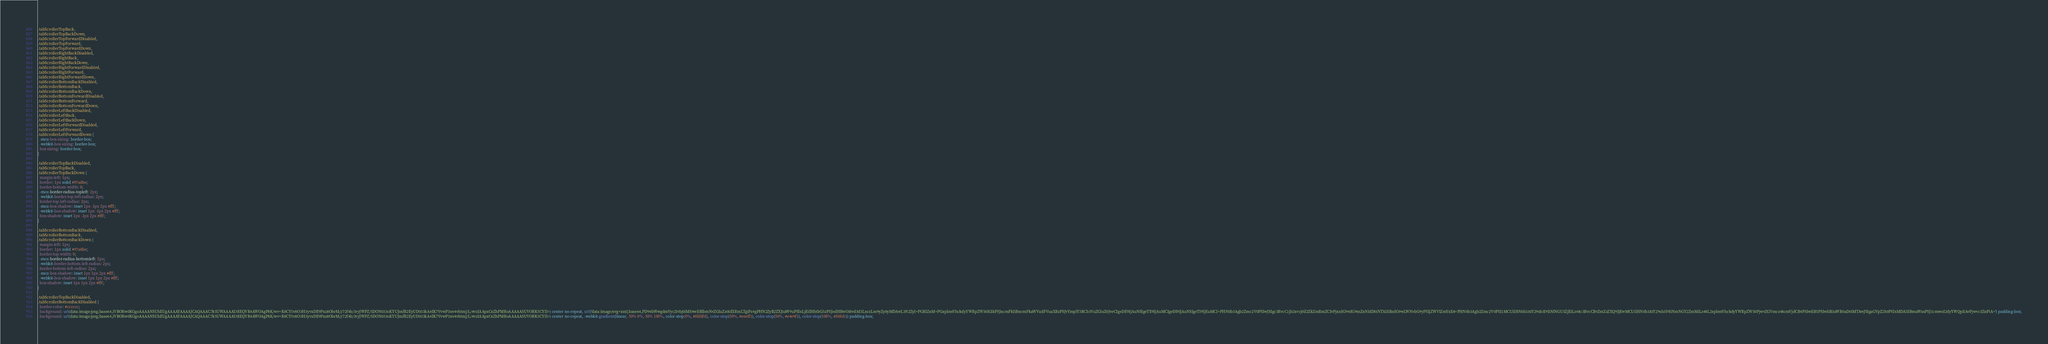Convert code to text. <code><loc_0><loc_0><loc_500><loc_500><_CSS_>.tabScrollerTopBack,
.tabScrollerTopBackDown,
.tabScrollerTopForwardDisabled,
.tabScrollerTopForward,
.tabScrollerTopForwardDown,
.tabScrollerRightBackDisabled,
.tabScrollerRightBack,
.tabScrollerRightBackDown,
.tabScrollerRightForwardDisabled,
.tabScrollerRightForward,
.tabScrollerRightForwardDown,
.tabScrollerBottomBackDisabled,
.tabScrollerBottomBack,
.tabScrollerBottomBackDown,
.tabScrollerBottomForwardDisabled,
.tabScrollerBottomForward,
.tabScrollerBottomForwardDown,
.tabScrollerLeftBackDisabled,
.tabScrollerLeftBack,
.tabScrollerLeftBackDown,
.tabScrollerLeftForwardDisabled,
.tabScrollerLeftForward,
.tabScrollerLeftForwardDown {
  -moz-box-sizing: border-box;
  -webkit-box-sizing: border-box;
  box-sizing: border-box;
}

.tabScrollerTopBackDisabled,
.tabScrollerTopBack,
.tabScrollerTopBackDown {
  margin-left: 1px;
  border: 1px solid #97a8be;
  border-bottom-width: 0;
  -moz-border-radius-topleft: 2px;
  -webkit-border-top-left-radius: 2px;
  border-top-left-radius: 2px;
  -moz-box-shadow: inset 1px -1px 2px #fff;
  -webkit-box-shadow: inset 1px -1px 2px #fff;
  box-shadow: inset 1px -1px 2px #fff;
}

.tabScrollerBottomBackDisabled,
.tabScrollerBottomBack,
.tabScrollerBottomBackDown {
  margin-left: 1px;
  border: 1px solid #97a8be;
  border-top-width: 0;
  -moz-border-radius-bottomleft: 2px;
  -webkit-border-bottom-left-radius: 2px;
  border-bottom-left-radius: 2px;
  -moz-box-shadow: inset 1px 1px 2px #fff;
  -webkit-box-shadow: inset 1px 1px 2px #fff;
  box-shadow: inset 1px 1px 2px #fff;
}

.tabScrollerTopBackDisabled,
.tabScrollerBottomBackDisabled {
  border-color: #cccccc;
  background: url(data:image/png;base64,iVBORw0KGgoAAAANSUhEUgAAAAYAAAAJCAQAAAC7k5UWAAAAU0lEQVR4AWOAgP8K/wv+K0CY5v8O3H3yvxDE9Pxz8ObrM///72f4b/3ryJWPZ/5DON033oKYUJmfR2EyUD033kA4IK7VvwP3nv4vhtmj/L/4vzIAApxC6ZhPMRoAAAAASUVORK5CYII=) center no-repeat, url('data:image/svg+xml;base64,PD94bWwgdmVyc2lvbj0iMS4wIiBlbmNvZGluZz0idXRmLTgiPz4gPHN2ZyB2ZXJzaW9uPSIxLjEiIHhtbG5zPSJodHRwOi8vd3d3LnczLm9yZy8yMDAwL3N2ZyI+PGRlZnM+PGxpbmVhckdyYWRpZW50IGlkPSJncmFkIiBncmFkaWVudFVuaXRzPSJvYmplY3RCb3VuZGluZ0JveCIgeDE9IjAuNSIgeTE9IjAuMCIgeDI9IjAuNSIgeTI9IjEuMCI+PHN0b3Agb2Zmc2V0PSIwJSIgc3RvcC1jb2xvcj0iI2ZkZmRmZCIvPjxzdG9wIG9mZnNldD0iNTAlIiBzdG9wLWNvbG9yPSIjZWVlZmYxIi8+PHN0b3Agb2Zmc2V0PSI1MCUiIHN0b3AtY29sb3I9IiNlNGU5ZjEiLz48c3RvcCBvZmZzZXQ9IjEwMCUiIHN0b3AtY29sb3I9IiNmNGY2ZmMiLz48L2xpbmVhckdyYWRpZW50PjwvZGVmcz48cmVjdCB4PSIwIiB5PSIwIiB3aWR0aD0iMTAwJSIgaGVpZ2h0PSIxMDAlIiBmaWxsPSJ1cmwoI2dyYWQpIiAvPjwvc3ZnPiA=') padding-box;
  background: url(data:image/png;base64,iVBORw0KGgoAAAANSUhEUgAAAAYAAAAJCAQAAAC7k5UWAAAAU0lEQVR4AWOAgP8K/wv+K0CY5v8O3H3yvxDE9Pxz8ObrM///72f4b/3ryJWPZ/5DON033oKYUJmfR2EyUD033kA4IK7VvwP3nv4vhtmj/L/4vzIAApxC6ZhPMRoAAAAASUVORK5CYII=) center no-repeat, -webkit-gradient(linear, 50% 0%, 50% 100%, color-stop(0%, #fdfdfd), color-stop(50%, #eeeff1), color-stop(50%, #e4e9f1), color-stop(100%, #f4f6fc)) padding-box;</code> 